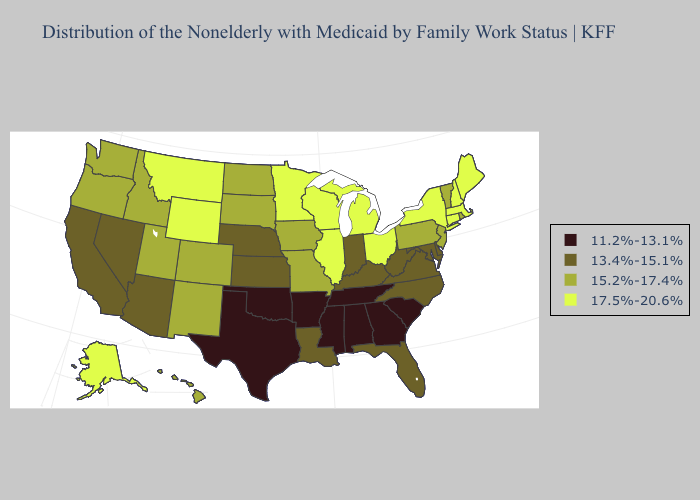Name the states that have a value in the range 13.4%-15.1%?
Concise answer only. Arizona, California, Delaware, Florida, Indiana, Kansas, Kentucky, Louisiana, Maryland, Nebraska, Nevada, North Carolina, Virginia, West Virginia. Among the states that border Nebraska , which have the lowest value?
Concise answer only. Kansas. Does Massachusetts have the lowest value in the Northeast?
Answer briefly. No. Name the states that have a value in the range 17.5%-20.6%?
Give a very brief answer. Alaska, Connecticut, Illinois, Maine, Massachusetts, Michigan, Minnesota, Montana, New Hampshire, New York, Ohio, Wisconsin, Wyoming. Does Texas have the lowest value in the USA?
Concise answer only. Yes. Name the states that have a value in the range 17.5%-20.6%?
Short answer required. Alaska, Connecticut, Illinois, Maine, Massachusetts, Michigan, Minnesota, Montana, New Hampshire, New York, Ohio, Wisconsin, Wyoming. Does Colorado have the lowest value in the USA?
Answer briefly. No. What is the lowest value in the Northeast?
Concise answer only. 15.2%-17.4%. Does South Dakota have the lowest value in the USA?
Give a very brief answer. No. Name the states that have a value in the range 17.5%-20.6%?
Concise answer only. Alaska, Connecticut, Illinois, Maine, Massachusetts, Michigan, Minnesota, Montana, New Hampshire, New York, Ohio, Wisconsin, Wyoming. Does North Dakota have a higher value than Connecticut?
Answer briefly. No. What is the highest value in the Northeast ?
Answer briefly. 17.5%-20.6%. Name the states that have a value in the range 17.5%-20.6%?
Be succinct. Alaska, Connecticut, Illinois, Maine, Massachusetts, Michigan, Minnesota, Montana, New Hampshire, New York, Ohio, Wisconsin, Wyoming. What is the value of Nevada?
Be succinct. 13.4%-15.1%. Name the states that have a value in the range 11.2%-13.1%?
Concise answer only. Alabama, Arkansas, Georgia, Mississippi, Oklahoma, South Carolina, Tennessee, Texas. 